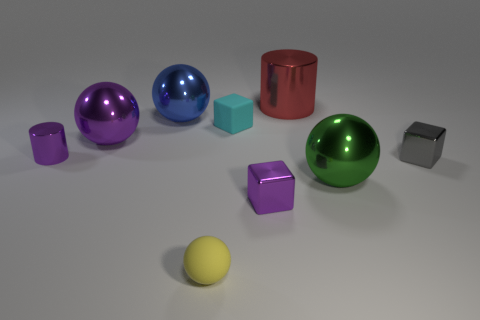There is a cylinder that is left of the tiny matte ball; what is its material?
Provide a short and direct response. Metal. Are there fewer blue balls that are in front of the tiny cyan cube than red cylinders?
Your response must be concise. Yes. There is a small purple object on the right side of the rubber ball that is in front of the tiny matte cube; what shape is it?
Provide a short and direct response. Cube. The big cylinder has what color?
Give a very brief answer. Red. How many other objects are there of the same size as the red object?
Provide a short and direct response. 3. The large ball that is left of the big red metallic object and in front of the blue sphere is made of what material?
Your answer should be very brief. Metal. Is the size of the cylinder to the right of the matte block the same as the big purple ball?
Ensure brevity in your answer.  Yes. Is the tiny cylinder the same color as the large shiny cylinder?
Provide a short and direct response. No. What number of objects are left of the cyan matte cube and in front of the large blue shiny sphere?
Offer a very short reply. 3. There is a tiny shiny object that is left of the rubber object that is behind the tiny gray shiny object; what number of tiny yellow matte balls are behind it?
Provide a short and direct response. 0. 